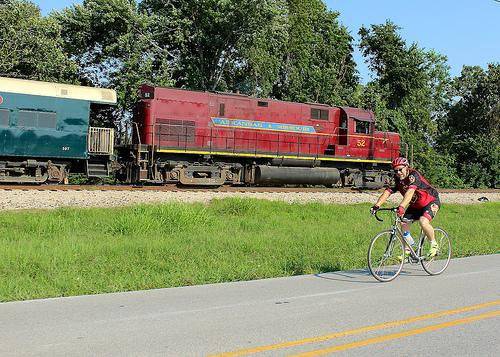Briefly describe any distinctive features of the train in the image. The train has a two-tone blue car, a blue banner, white clouds in the blue sky, and the number 52 on it. What color and pattern are the bicyclist's shirt and shorts? The bicyclist is wearing a black and red shirt and black and red shorts. What is the number and color of the logo on the train? The yellow 52 logo is on the train. List 3 safety-related items or features that can be observed in the image. A red biker's helmet, a man wearing sunglasses, and green shoes on the man. Count the number of grassy areas in the image and give their main colors. There are four short green and brown grassy areas in the image. Write a short description of the overall scene in the image. A man is riding a bike next to train tracks, while a train passes by. There are yellow lines on the road, trees lining the tracks, and grass and rocks alongside the tracks. Write a brief narrative of the man's journey on the bike, as depicted in the image. A man wearing a helmet, sunglasses, and green shoes swiftly pedals his bike along a road with yellow lines, as he rides parallel to rusted train tracks and a dusty red train engine. Surrounding him are trees, grass, and rocks, adding to the scenic beauty of his journey. What type of vehicle is in the image and what is its color? A dusty red train engine is in the image. Describe the condition of the road and train tracks depicted in the image. The road has yellow lines painted on it, and the train tracks are rusted metal with debris on the side. Is the train next to the trees green in color? The real attributes mention the trains as being two-tone blue and dusty red, but not green. Are the clouds in the sky red in color? The real attributes mention white clouds in blue sky, but not red clouds. Is the grass next to the man pink in color? The real attributes mention short green and brown grass, but not pink grass. Is the helmet on the man riding the bike orange? The real attributes mention the helmet as being bright red, but not orange. Are the lines on the road purple? The real attributes mention the lines on the road as being yellow, but not purple. Does the man riding the bike have blue shoes on? The real attributes mention the man wearing green shoes, but not blue shoes. 